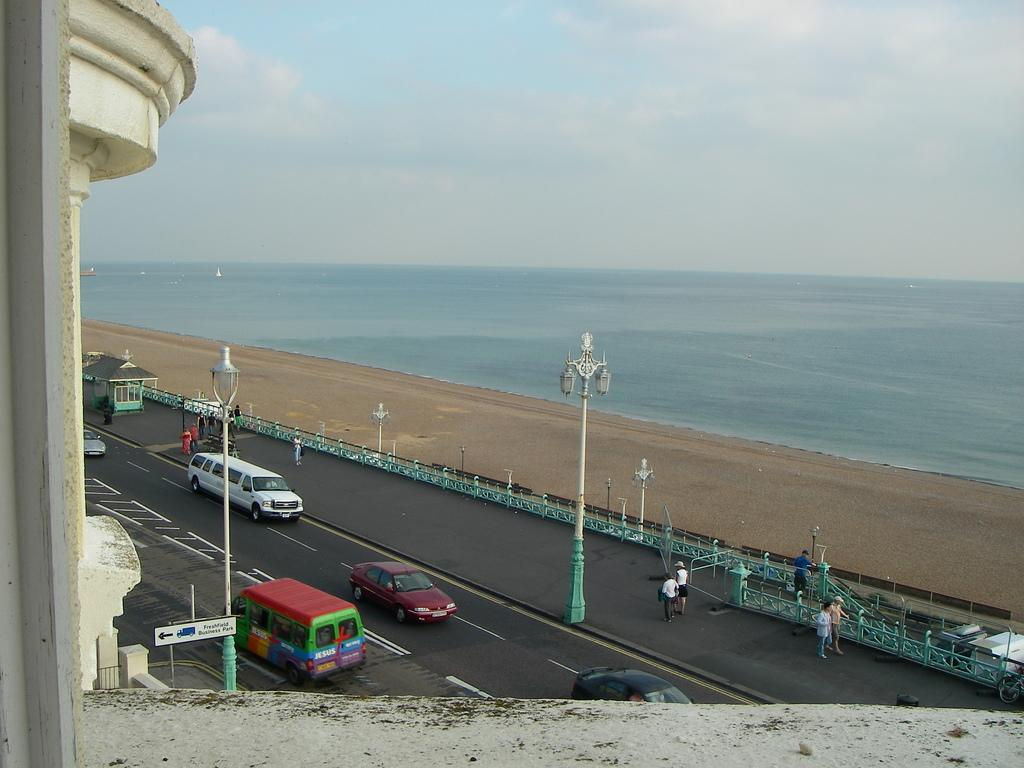What can be seen on the road in the image? There are vehicles on the road in the image. What type of terrain is visible in the image? There is sand visible in the image. What can be seen illuminating the scene in the image? There are lights in the image. Who or what is present in the image? There are persons in the image. What natural elements can be seen in the image? There is water visible in the image. What part of the natural environment is visible in the image? There is sky visible in the image, and there are clouds in the sky. How many babies are crawling on the sand in the image? There are no babies present in the image; it features vehicles on the road, sand, lights, persons, water, sky, and clouds. What type of motion can be seen in the image? The image does not depict any specific motion; it shows vehicles, sand, lights, persons, water, sky, and clouds in a static scene. 